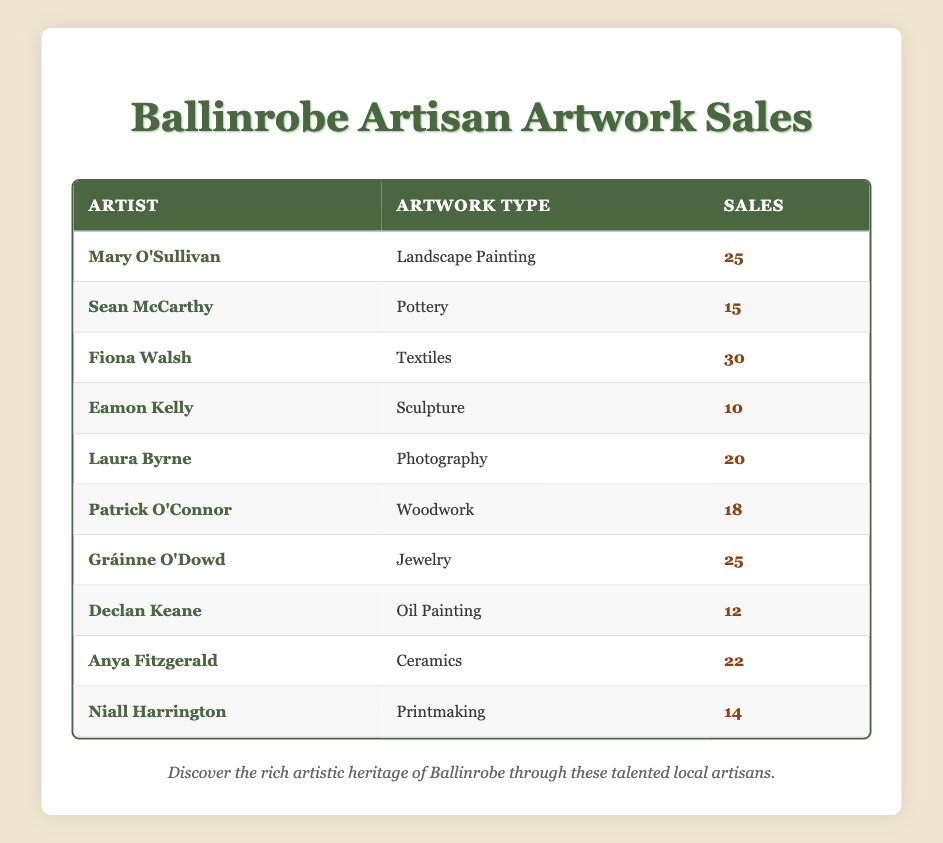What is the total sales from all artists? To find the total sales, sum the sales from each artist: 25 + 15 + 30 + 10 + 20 + 18 + 25 + 12 + 22 + 14 =  25 + 15 = 40, 40 + 30 = 70, 70 + 10 = 80, 80 + 20 = 100, 100 + 18 = 118, 118 + 25 = 143, 143 + 12 = 155, 155 + 22 = 177, 177 + 14 = 191
Answer: 191 Who had the highest sales and what was the artwork type? By reviewing the sales figures, Fiona Walsh had the highest sales at 30, and her artwork type is Textiles.
Answer: Fiona Walsh, Textiles Is there any artist who sold less than 15 artworks? Yes, Eamon Kelly sold 10 sculptures, and Sean McCarthy sold 15 pottery works.
Answer: Yes What is the average number of sales per type of artwork? To get the average, first sum all sales (191) and divide by the number of artwork types (10): 191 / 10 = 19.1
Answer: 19.1 Does Gráinne O'Dowd have more sales than Laura Byrne? Gráinne O'Dowd sold 25 artworks while Laura Byrne sold 20, so Gráinne O'Dowd has more sales.
Answer: Yes How many sales did artists in the painting category achieve in total? Mary O'Sullivan (25), Fiona Walsh (30), Eamon Kelly (10), and Declan Keane (12) sold paintings. Their total is 25 + 30 + 10 + 12 = 77.
Answer: 77 Which type of artwork had the least sales and how many were sold? The artwork with the least sales is Sculpture, sold by Eamon Kelly, with 10 sales.
Answer: Sculpture, 10 Are there more artists specializing in clay-based artworks (Pottery, Ceramics) than in textile-based artworks? There are 2 clay-based artists (Sean McCarthy for Pottery and Anya Fitzgerald for Ceramics) and 1 textile artist (Fiona Walsh). Thus, there are more clay-oriented artists.
Answer: Yes What is the difference in sales between the artist with the highest sales and the artist with the lowest sales? The highest sales are from Fiona Walsh (30), and the lowest are from Eamon Kelly (10). The difference is 30 - 10 = 20.
Answer: 20 